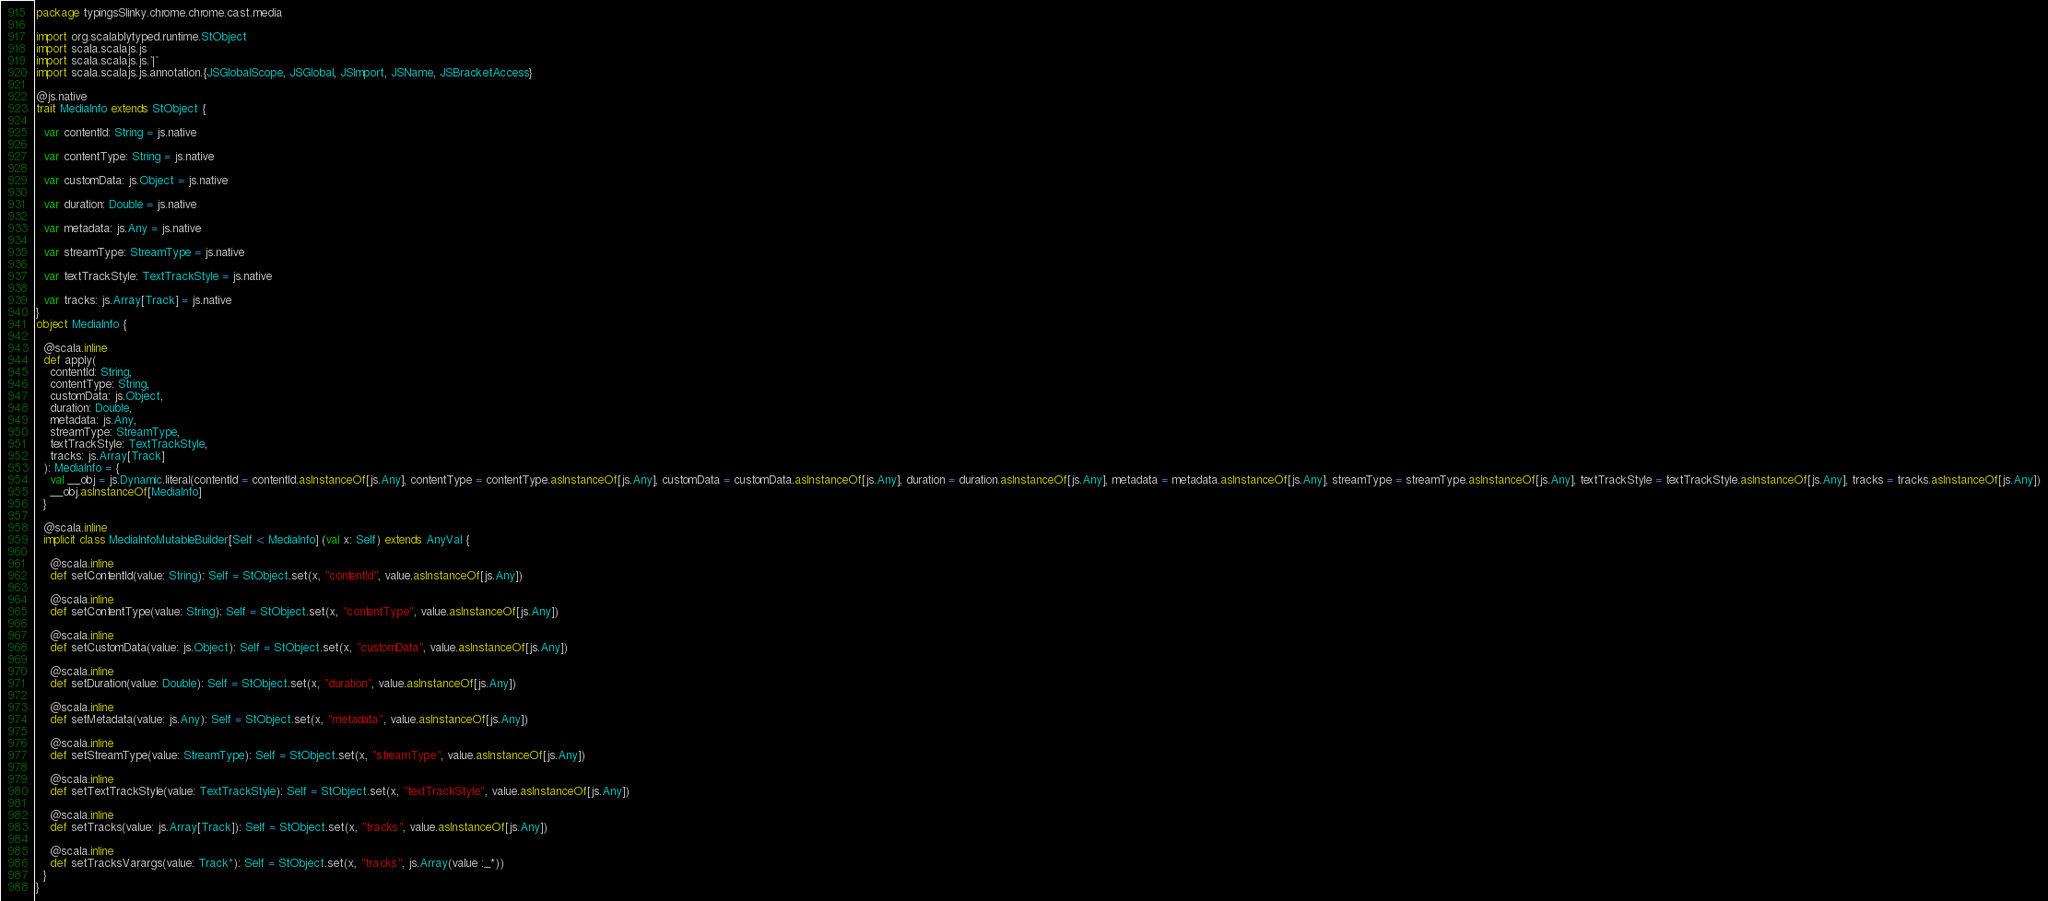Convert code to text. <code><loc_0><loc_0><loc_500><loc_500><_Scala_>package typingsSlinky.chrome.chrome.cast.media

import org.scalablytyped.runtime.StObject
import scala.scalajs.js
import scala.scalajs.js.`|`
import scala.scalajs.js.annotation.{JSGlobalScope, JSGlobal, JSImport, JSName, JSBracketAccess}

@js.native
trait MediaInfo extends StObject {
  
  var contentId: String = js.native
  
  var contentType: String = js.native
  
  var customData: js.Object = js.native
  
  var duration: Double = js.native
  
  var metadata: js.Any = js.native
  
  var streamType: StreamType = js.native
  
  var textTrackStyle: TextTrackStyle = js.native
  
  var tracks: js.Array[Track] = js.native
}
object MediaInfo {
  
  @scala.inline
  def apply(
    contentId: String,
    contentType: String,
    customData: js.Object,
    duration: Double,
    metadata: js.Any,
    streamType: StreamType,
    textTrackStyle: TextTrackStyle,
    tracks: js.Array[Track]
  ): MediaInfo = {
    val __obj = js.Dynamic.literal(contentId = contentId.asInstanceOf[js.Any], contentType = contentType.asInstanceOf[js.Any], customData = customData.asInstanceOf[js.Any], duration = duration.asInstanceOf[js.Any], metadata = metadata.asInstanceOf[js.Any], streamType = streamType.asInstanceOf[js.Any], textTrackStyle = textTrackStyle.asInstanceOf[js.Any], tracks = tracks.asInstanceOf[js.Any])
    __obj.asInstanceOf[MediaInfo]
  }
  
  @scala.inline
  implicit class MediaInfoMutableBuilder[Self <: MediaInfo] (val x: Self) extends AnyVal {
    
    @scala.inline
    def setContentId(value: String): Self = StObject.set(x, "contentId", value.asInstanceOf[js.Any])
    
    @scala.inline
    def setContentType(value: String): Self = StObject.set(x, "contentType", value.asInstanceOf[js.Any])
    
    @scala.inline
    def setCustomData(value: js.Object): Self = StObject.set(x, "customData", value.asInstanceOf[js.Any])
    
    @scala.inline
    def setDuration(value: Double): Self = StObject.set(x, "duration", value.asInstanceOf[js.Any])
    
    @scala.inline
    def setMetadata(value: js.Any): Self = StObject.set(x, "metadata", value.asInstanceOf[js.Any])
    
    @scala.inline
    def setStreamType(value: StreamType): Self = StObject.set(x, "streamType", value.asInstanceOf[js.Any])
    
    @scala.inline
    def setTextTrackStyle(value: TextTrackStyle): Self = StObject.set(x, "textTrackStyle", value.asInstanceOf[js.Any])
    
    @scala.inline
    def setTracks(value: js.Array[Track]): Self = StObject.set(x, "tracks", value.asInstanceOf[js.Any])
    
    @scala.inline
    def setTracksVarargs(value: Track*): Self = StObject.set(x, "tracks", js.Array(value :_*))
  }
}
</code> 